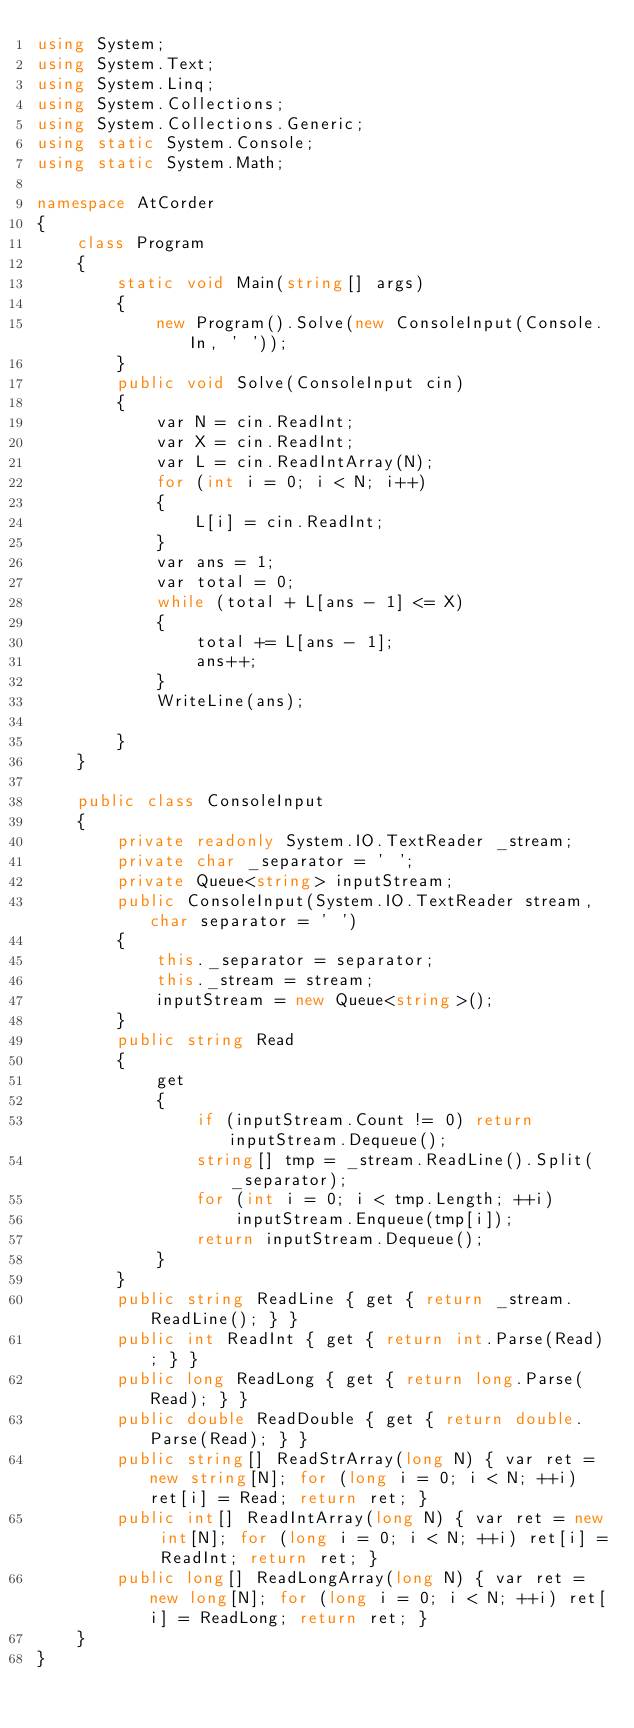<code> <loc_0><loc_0><loc_500><loc_500><_C#_>using System;
using System.Text;
using System.Linq;
using System.Collections;
using System.Collections.Generic;
using static System.Console;
using static System.Math;

namespace AtCorder
{
    class Program
    {
        static void Main(string[] args)
        {
            new Program().Solve(new ConsoleInput(Console.In, ' '));
        }
        public void Solve(ConsoleInput cin)
        {
            var N = cin.ReadInt;
            var X = cin.ReadInt;
            var L = cin.ReadIntArray(N);
            for (int i = 0; i < N; i++)
            {
                L[i] = cin.ReadInt;
            }
            var ans = 1;
            var total = 0;
            while (total + L[ans - 1] <= X)
            {
                total += L[ans - 1];
                ans++;
            }
            WriteLine(ans);

        }
    }

    public class ConsoleInput
    {
        private readonly System.IO.TextReader _stream;
        private char _separator = ' ';
        private Queue<string> inputStream;
        public ConsoleInput(System.IO.TextReader stream, char separator = ' ')
        {
            this._separator = separator;
            this._stream = stream;
            inputStream = new Queue<string>();
        }
        public string Read
        {
            get
            {
                if (inputStream.Count != 0) return inputStream.Dequeue();
                string[] tmp = _stream.ReadLine().Split(_separator);
                for (int i = 0; i < tmp.Length; ++i)
                    inputStream.Enqueue(tmp[i]);
                return inputStream.Dequeue();
            }
        }
        public string ReadLine { get { return _stream.ReadLine(); } }
        public int ReadInt { get { return int.Parse(Read); } }
        public long ReadLong { get { return long.Parse(Read); } }
        public double ReadDouble { get { return double.Parse(Read); } }
        public string[] ReadStrArray(long N) { var ret = new string[N]; for (long i = 0; i < N; ++i) ret[i] = Read; return ret; }
        public int[] ReadIntArray(long N) { var ret = new int[N]; for (long i = 0; i < N; ++i) ret[i] = ReadInt; return ret; }
        public long[] ReadLongArray(long N) { var ret = new long[N]; for (long i = 0; i < N; ++i) ret[i] = ReadLong; return ret; }
    }
}</code> 